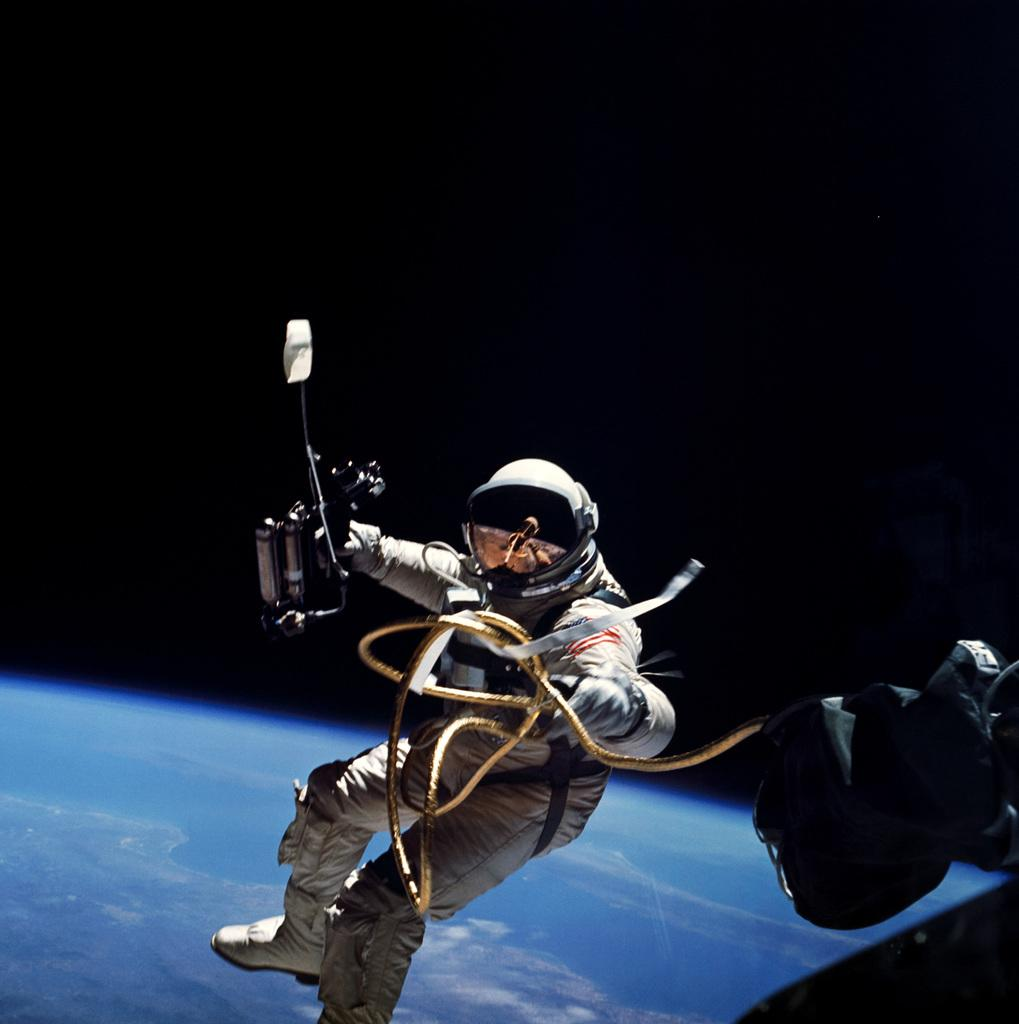What is the main subject of the image? There is a person in the image. What is the person wearing? The person is wearing a white dress and a helmet. What is the person holding in the image? The person is holding something. Can you describe the background of the image? There is a black and blue background in the image. What type of lettuce can be seen growing in the image? There is no lettuce present in the image. What scientific experiment is being conducted in the image? There is no scientific experiment depicted in the image. 